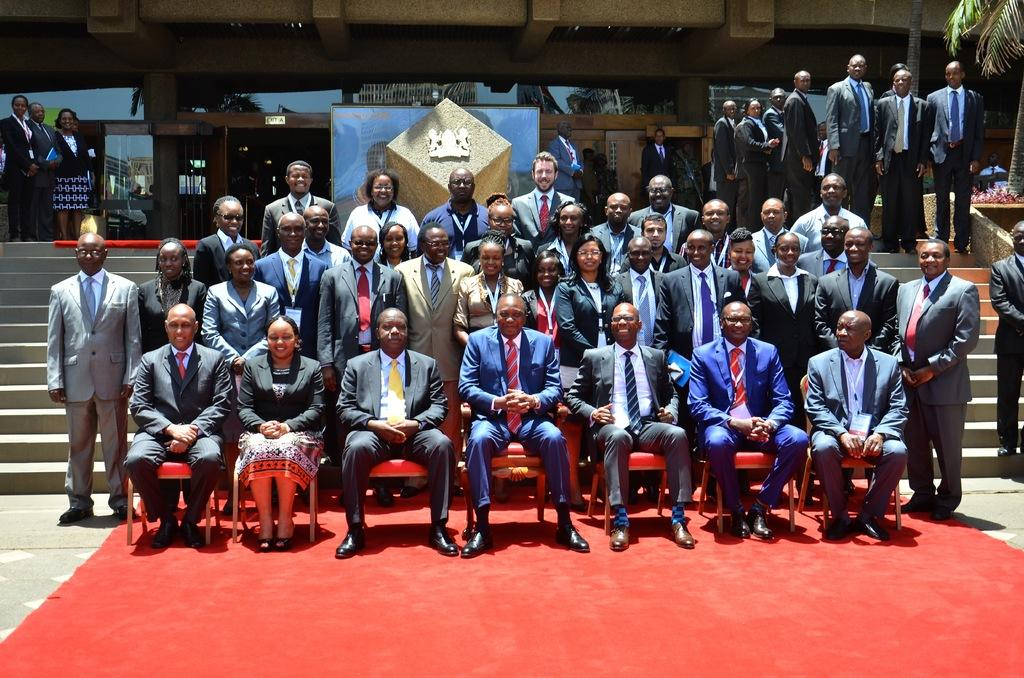What are the people in the image doing? The people in the image are sitting and standing. What are the people sitting on? The people sitting are on chairs. What type of wing is visible in the image? There is no wing present in the image. Are there any doctors in the image? The provided facts do not mention any doctors in the image. 